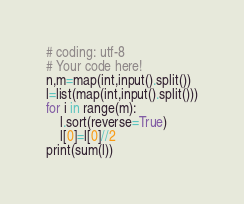<code> <loc_0><loc_0><loc_500><loc_500><_Python_># coding: utf-8
# Your code here!
n,m=map(int,input().split())
l=list(map(int,input().split()))
for i in range(m):
    l.sort(reverse=True)
    l[0]=l[0]//2
print(sum(l))

</code> 